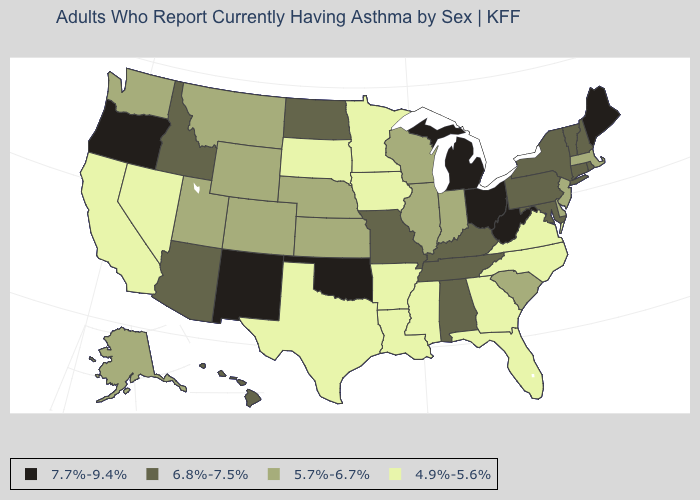Does Oregon have the lowest value in the West?
Write a very short answer. No. What is the highest value in the USA?
Be succinct. 7.7%-9.4%. Which states have the highest value in the USA?
Quick response, please. Maine, Michigan, New Mexico, Ohio, Oklahoma, Oregon, West Virginia. What is the value of Texas?
Short answer required. 4.9%-5.6%. Does New Mexico have the lowest value in the USA?
Write a very short answer. No. Name the states that have a value in the range 4.9%-5.6%?
Answer briefly. Arkansas, California, Florida, Georgia, Iowa, Louisiana, Minnesota, Mississippi, Nevada, North Carolina, South Dakota, Texas, Virginia. Does Georgia have the lowest value in the USA?
Give a very brief answer. Yes. How many symbols are there in the legend?
Give a very brief answer. 4. Which states have the lowest value in the Northeast?
Be succinct. Massachusetts, New Jersey. Does California have a lower value than Indiana?
Concise answer only. Yes. Which states have the highest value in the USA?
Be succinct. Maine, Michigan, New Mexico, Ohio, Oklahoma, Oregon, West Virginia. Name the states that have a value in the range 6.8%-7.5%?
Short answer required. Alabama, Arizona, Connecticut, Hawaii, Idaho, Kentucky, Maryland, Missouri, New Hampshire, New York, North Dakota, Pennsylvania, Rhode Island, Tennessee, Vermont. Which states have the lowest value in the Northeast?
Short answer required. Massachusetts, New Jersey. What is the lowest value in the South?
Answer briefly. 4.9%-5.6%. Does the first symbol in the legend represent the smallest category?
Write a very short answer. No. 